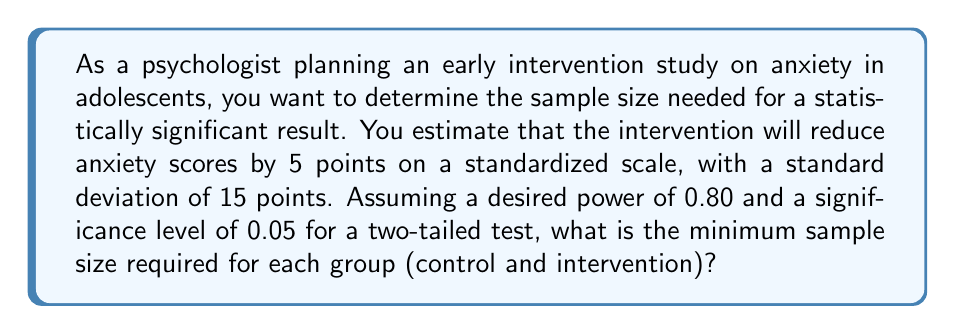Teach me how to tackle this problem. To determine the sample size, we'll use the formula for a two-sample t-test:

$$n = \frac{2(z_{\alpha/2} + z_{\beta})^2\sigma^2}{\Delta^2}$$

Where:
$n$ = sample size per group
$z_{\alpha/2}$ = z-score for the significance level (α/2)
$z_{\beta}$ = z-score for the desired power (1 - β)
$\sigma$ = standard deviation
$\Delta$ = expected difference between groups

Step 1: Identify the known values
- Significance level (α) = 0.05 (two-tailed)
- Desired power (1 - β) = 0.80
- Standard deviation (σ) = 15
- Expected difference (Δ) = 5

Step 2: Find the z-scores
- For α/2 = 0.025, $z_{\alpha/2}$ = 1.96
- For β = 0.20, $z_{\beta}$ = 0.84

Step 3: Plug the values into the formula
$$n = \frac{2(1.96 + 0.84)^2 15^2}{5^2}$$

Step 4: Solve the equation
$$n = \frac{2(2.8)^2 225}{25} = \frac{2(7.84)(225)}{25} = \frac{3,528}{25} = 141.12$$

Step 5: Round up to the nearest whole number
$n ≈ 142$

Therefore, you need at least 142 participants in each group (control and intervention) for a total of 284 participants.
Answer: 142 participants per group 